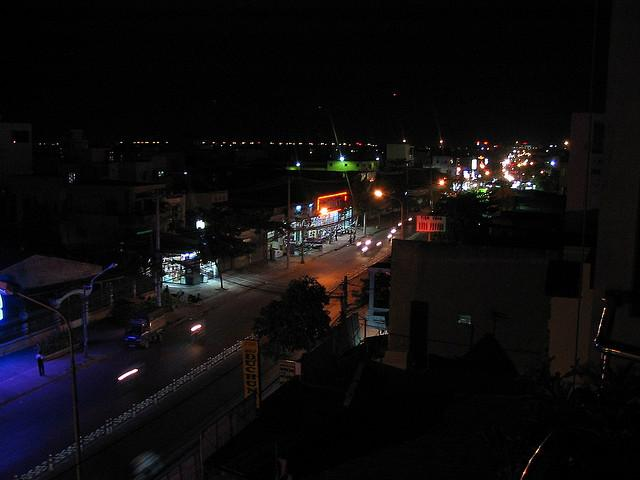What are is the image from? Please explain your reasoning. city. The area has bright lights and many buildings. 